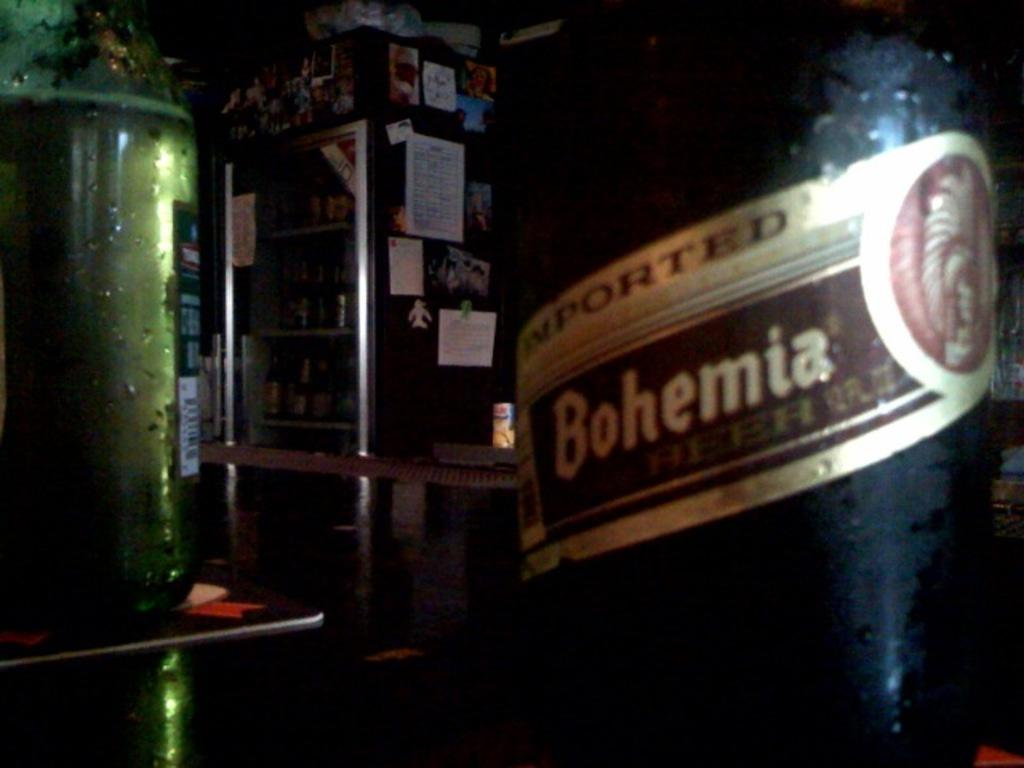<image>
Describe the image concisely. A bottle of Bohemia that is imported is next to a green bottle. 